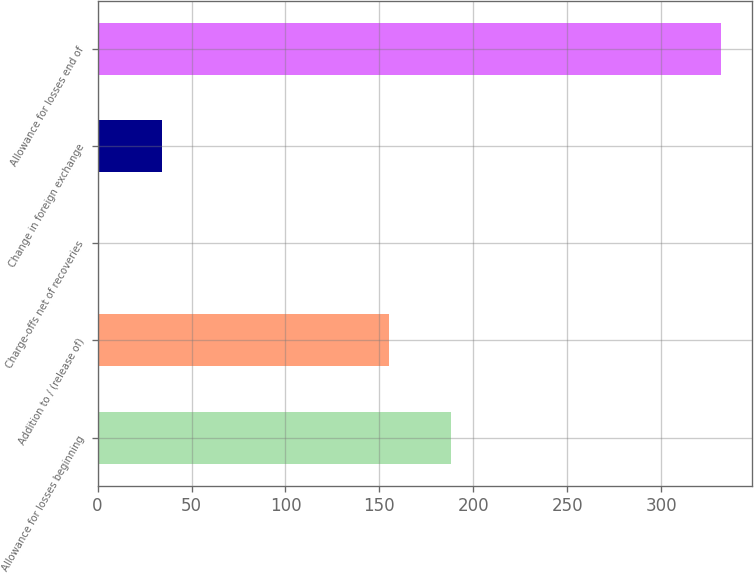Convert chart to OTSL. <chart><loc_0><loc_0><loc_500><loc_500><bar_chart><fcel>Allowance for losses beginning<fcel>Addition to / (release of)<fcel>Charge-offs net of recoveries<fcel>Change in foreign exchange<fcel>Allowance for losses end of<nl><fcel>188.1<fcel>155<fcel>1<fcel>34.1<fcel>332<nl></chart> 